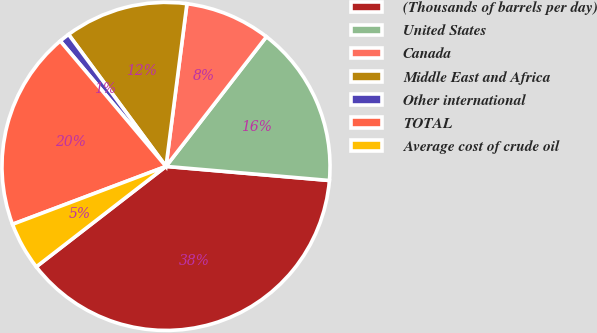Convert chart to OTSL. <chart><loc_0><loc_0><loc_500><loc_500><pie_chart><fcel>(Thousands of barrels per day)<fcel>United States<fcel>Canada<fcel>Middle East and Africa<fcel>Other international<fcel>TOTAL<fcel>Average cost of crude oil<nl><fcel>38.15%<fcel>15.88%<fcel>8.45%<fcel>12.16%<fcel>1.03%<fcel>19.59%<fcel>4.74%<nl></chart> 